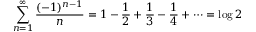Convert formula to latex. <formula><loc_0><loc_0><loc_500><loc_500>\sum _ { n = 1 } ^ { \infty } { \frac { ( - 1 ) ^ { n - 1 } } { n } } = 1 - { \frac { 1 } { 2 } } + { \frac { 1 } { 3 } } - { \frac { 1 } { 4 } } + \cdots = \log 2</formula> 